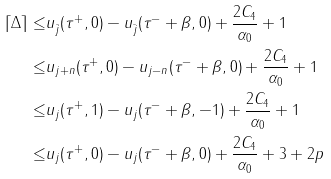<formula> <loc_0><loc_0><loc_500><loc_500>\lceil \Delta \rceil \leq & u _ { \bar { j } } ( \tau ^ { + } , 0 ) - u _ { \bar { j } } ( \tau ^ { - } + \beta , 0 ) + \frac { 2 C _ { 4 } } { \alpha _ { 0 } } + 1 \\ \leq & u _ { j + n } ( \tau ^ { + } , 0 ) - u _ { j - n } ( \tau ^ { - } + \beta , 0 ) + \frac { 2 C _ { 4 } } { \alpha _ { 0 } } + 1 \\ \leq & u _ { j } ( \tau ^ { + } , 1 ) - u _ { j } ( \tau ^ { - } + \beta , - 1 ) + \frac { 2 C _ { 4 } } { \alpha _ { 0 } } + 1 \\ \leq & u _ { j } ( \tau ^ { + } , 0 ) - u _ { j } ( \tau ^ { - } + \beta , 0 ) + \frac { 2 C _ { 4 } } { \alpha _ { 0 } } + 3 + 2 p</formula> 